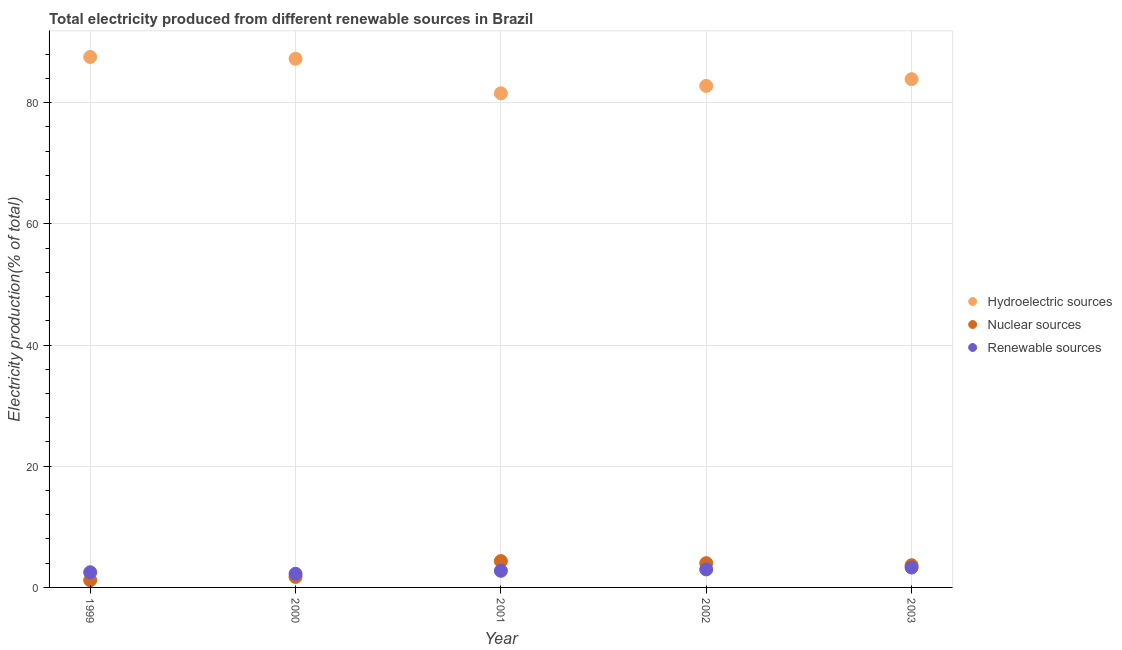How many different coloured dotlines are there?
Ensure brevity in your answer.  3. What is the percentage of electricity produced by hydroelectric sources in 2003?
Make the answer very short. 83.88. Across all years, what is the maximum percentage of electricity produced by hydroelectric sources?
Make the answer very short. 87.54. Across all years, what is the minimum percentage of electricity produced by hydroelectric sources?
Ensure brevity in your answer.  81.54. In which year was the percentage of electricity produced by hydroelectric sources minimum?
Provide a short and direct response. 2001. What is the total percentage of electricity produced by nuclear sources in the graph?
Offer a very short reply. 14.94. What is the difference between the percentage of electricity produced by hydroelectric sources in 1999 and that in 2001?
Your answer should be very brief. 5.99. What is the difference between the percentage of electricity produced by renewable sources in 2003 and the percentage of electricity produced by nuclear sources in 2001?
Offer a very short reply. -1.07. What is the average percentage of electricity produced by renewable sources per year?
Provide a succinct answer. 2.75. In the year 2003, what is the difference between the percentage of electricity produced by renewable sources and percentage of electricity produced by nuclear sources?
Offer a terse response. -0.39. In how many years, is the percentage of electricity produced by nuclear sources greater than 40 %?
Provide a succinct answer. 0. What is the ratio of the percentage of electricity produced by nuclear sources in 2002 to that in 2003?
Ensure brevity in your answer.  1.09. Is the difference between the percentage of electricity produced by renewable sources in 1999 and 2002 greater than the difference between the percentage of electricity produced by nuclear sources in 1999 and 2002?
Give a very brief answer. Yes. What is the difference between the highest and the second highest percentage of electricity produced by nuclear sources?
Ensure brevity in your answer.  0.34. What is the difference between the highest and the lowest percentage of electricity produced by renewable sources?
Offer a terse response. 1.03. In how many years, is the percentage of electricity produced by nuclear sources greater than the average percentage of electricity produced by nuclear sources taken over all years?
Your answer should be compact. 3. Is it the case that in every year, the sum of the percentage of electricity produced by hydroelectric sources and percentage of electricity produced by nuclear sources is greater than the percentage of electricity produced by renewable sources?
Your answer should be very brief. Yes. Does the percentage of electricity produced by renewable sources monotonically increase over the years?
Your answer should be compact. No. Is the percentage of electricity produced by nuclear sources strictly less than the percentage of electricity produced by hydroelectric sources over the years?
Your answer should be very brief. Yes. What is the difference between two consecutive major ticks on the Y-axis?
Your answer should be compact. 20. Are the values on the major ticks of Y-axis written in scientific E-notation?
Your answer should be compact. No. Does the graph contain any zero values?
Give a very brief answer. No. What is the title of the graph?
Ensure brevity in your answer.  Total electricity produced from different renewable sources in Brazil. Does "Negligence towards kids" appear as one of the legend labels in the graph?
Make the answer very short. No. What is the Electricity production(% of total) in Hydroelectric sources in 1999?
Provide a short and direct response. 87.54. What is the Electricity production(% of total) of Nuclear sources in 1999?
Offer a terse response. 1.19. What is the Electricity production(% of total) of Renewable sources in 1999?
Give a very brief answer. 2.5. What is the Electricity production(% of total) of Hydroelectric sources in 2000?
Give a very brief answer. 87.24. What is the Electricity production(% of total) of Nuclear sources in 2000?
Offer a terse response. 1.73. What is the Electricity production(% of total) of Renewable sources in 2000?
Provide a succinct answer. 2.25. What is the Electricity production(% of total) in Hydroelectric sources in 2001?
Make the answer very short. 81.54. What is the Electricity production(% of total) of Nuclear sources in 2001?
Your response must be concise. 4.35. What is the Electricity production(% of total) of Renewable sources in 2001?
Offer a very short reply. 2.74. What is the Electricity production(% of total) in Hydroelectric sources in 2002?
Your response must be concise. 82.76. What is the Electricity production(% of total) of Nuclear sources in 2002?
Provide a succinct answer. 4. What is the Electricity production(% of total) in Renewable sources in 2002?
Make the answer very short. 2.97. What is the Electricity production(% of total) of Hydroelectric sources in 2003?
Provide a succinct answer. 83.88. What is the Electricity production(% of total) of Nuclear sources in 2003?
Offer a terse response. 3.67. What is the Electricity production(% of total) of Renewable sources in 2003?
Your answer should be compact. 3.28. Across all years, what is the maximum Electricity production(% of total) of Hydroelectric sources?
Make the answer very short. 87.54. Across all years, what is the maximum Electricity production(% of total) in Nuclear sources?
Provide a succinct answer. 4.35. Across all years, what is the maximum Electricity production(% of total) in Renewable sources?
Ensure brevity in your answer.  3.28. Across all years, what is the minimum Electricity production(% of total) of Hydroelectric sources?
Your answer should be compact. 81.54. Across all years, what is the minimum Electricity production(% of total) of Nuclear sources?
Your answer should be very brief. 1.19. Across all years, what is the minimum Electricity production(% of total) of Renewable sources?
Offer a terse response. 2.25. What is the total Electricity production(% of total) of Hydroelectric sources in the graph?
Keep it short and to the point. 422.97. What is the total Electricity production(% of total) of Nuclear sources in the graph?
Make the answer very short. 14.94. What is the total Electricity production(% of total) of Renewable sources in the graph?
Your answer should be compact. 13.75. What is the difference between the Electricity production(% of total) in Hydroelectric sources in 1999 and that in 2000?
Offer a very short reply. 0.29. What is the difference between the Electricity production(% of total) of Nuclear sources in 1999 and that in 2000?
Provide a succinct answer. -0.54. What is the difference between the Electricity production(% of total) in Renewable sources in 1999 and that in 2000?
Give a very brief answer. 0.25. What is the difference between the Electricity production(% of total) of Hydroelectric sources in 1999 and that in 2001?
Your answer should be very brief. 5.99. What is the difference between the Electricity production(% of total) of Nuclear sources in 1999 and that in 2001?
Give a very brief answer. -3.16. What is the difference between the Electricity production(% of total) of Renewable sources in 1999 and that in 2001?
Provide a short and direct response. -0.24. What is the difference between the Electricity production(% of total) in Hydroelectric sources in 1999 and that in 2002?
Offer a terse response. 4.77. What is the difference between the Electricity production(% of total) of Nuclear sources in 1999 and that in 2002?
Your answer should be very brief. -2.81. What is the difference between the Electricity production(% of total) of Renewable sources in 1999 and that in 2002?
Provide a succinct answer. -0.47. What is the difference between the Electricity production(% of total) of Hydroelectric sources in 1999 and that in 2003?
Provide a succinct answer. 3.65. What is the difference between the Electricity production(% of total) in Nuclear sources in 1999 and that in 2003?
Your answer should be very brief. -2.48. What is the difference between the Electricity production(% of total) of Renewable sources in 1999 and that in 2003?
Your answer should be very brief. -0.78. What is the difference between the Electricity production(% of total) in Hydroelectric sources in 2000 and that in 2001?
Offer a very short reply. 5.7. What is the difference between the Electricity production(% of total) of Nuclear sources in 2000 and that in 2001?
Keep it short and to the point. -2.61. What is the difference between the Electricity production(% of total) in Renewable sources in 2000 and that in 2001?
Give a very brief answer. -0.5. What is the difference between the Electricity production(% of total) of Hydroelectric sources in 2000 and that in 2002?
Keep it short and to the point. 4.48. What is the difference between the Electricity production(% of total) in Nuclear sources in 2000 and that in 2002?
Give a very brief answer. -2.27. What is the difference between the Electricity production(% of total) of Renewable sources in 2000 and that in 2002?
Give a very brief answer. -0.73. What is the difference between the Electricity production(% of total) of Hydroelectric sources in 2000 and that in 2003?
Make the answer very short. 3.36. What is the difference between the Electricity production(% of total) of Nuclear sources in 2000 and that in 2003?
Make the answer very short. -1.93. What is the difference between the Electricity production(% of total) of Renewable sources in 2000 and that in 2003?
Ensure brevity in your answer.  -1.03. What is the difference between the Electricity production(% of total) of Hydroelectric sources in 2001 and that in 2002?
Offer a very short reply. -1.22. What is the difference between the Electricity production(% of total) of Nuclear sources in 2001 and that in 2002?
Ensure brevity in your answer.  0.34. What is the difference between the Electricity production(% of total) of Renewable sources in 2001 and that in 2002?
Give a very brief answer. -0.23. What is the difference between the Electricity production(% of total) of Hydroelectric sources in 2001 and that in 2003?
Your response must be concise. -2.34. What is the difference between the Electricity production(% of total) in Nuclear sources in 2001 and that in 2003?
Make the answer very short. 0.68. What is the difference between the Electricity production(% of total) in Renewable sources in 2001 and that in 2003?
Give a very brief answer. -0.54. What is the difference between the Electricity production(% of total) in Hydroelectric sources in 2002 and that in 2003?
Provide a succinct answer. -1.12. What is the difference between the Electricity production(% of total) of Nuclear sources in 2002 and that in 2003?
Provide a succinct answer. 0.34. What is the difference between the Electricity production(% of total) of Renewable sources in 2002 and that in 2003?
Make the answer very short. -0.31. What is the difference between the Electricity production(% of total) of Hydroelectric sources in 1999 and the Electricity production(% of total) of Nuclear sources in 2000?
Your answer should be compact. 85.8. What is the difference between the Electricity production(% of total) in Hydroelectric sources in 1999 and the Electricity production(% of total) in Renewable sources in 2000?
Provide a short and direct response. 85.29. What is the difference between the Electricity production(% of total) of Nuclear sources in 1999 and the Electricity production(% of total) of Renewable sources in 2000?
Your answer should be compact. -1.06. What is the difference between the Electricity production(% of total) in Hydroelectric sources in 1999 and the Electricity production(% of total) in Nuclear sources in 2001?
Provide a succinct answer. 83.19. What is the difference between the Electricity production(% of total) in Hydroelectric sources in 1999 and the Electricity production(% of total) in Renewable sources in 2001?
Ensure brevity in your answer.  84.79. What is the difference between the Electricity production(% of total) of Nuclear sources in 1999 and the Electricity production(% of total) of Renewable sources in 2001?
Your response must be concise. -1.56. What is the difference between the Electricity production(% of total) of Hydroelectric sources in 1999 and the Electricity production(% of total) of Nuclear sources in 2002?
Make the answer very short. 83.53. What is the difference between the Electricity production(% of total) of Hydroelectric sources in 1999 and the Electricity production(% of total) of Renewable sources in 2002?
Your answer should be very brief. 84.56. What is the difference between the Electricity production(% of total) of Nuclear sources in 1999 and the Electricity production(% of total) of Renewable sources in 2002?
Offer a very short reply. -1.79. What is the difference between the Electricity production(% of total) in Hydroelectric sources in 1999 and the Electricity production(% of total) in Nuclear sources in 2003?
Ensure brevity in your answer.  83.87. What is the difference between the Electricity production(% of total) of Hydroelectric sources in 1999 and the Electricity production(% of total) of Renewable sources in 2003?
Your answer should be compact. 84.26. What is the difference between the Electricity production(% of total) in Nuclear sources in 1999 and the Electricity production(% of total) in Renewable sources in 2003?
Your answer should be very brief. -2.09. What is the difference between the Electricity production(% of total) of Hydroelectric sources in 2000 and the Electricity production(% of total) of Nuclear sources in 2001?
Provide a short and direct response. 82.9. What is the difference between the Electricity production(% of total) of Hydroelectric sources in 2000 and the Electricity production(% of total) of Renewable sources in 2001?
Provide a short and direct response. 84.5. What is the difference between the Electricity production(% of total) of Nuclear sources in 2000 and the Electricity production(% of total) of Renewable sources in 2001?
Your answer should be compact. -1.01. What is the difference between the Electricity production(% of total) in Hydroelectric sources in 2000 and the Electricity production(% of total) in Nuclear sources in 2002?
Give a very brief answer. 83.24. What is the difference between the Electricity production(% of total) of Hydroelectric sources in 2000 and the Electricity production(% of total) of Renewable sources in 2002?
Offer a very short reply. 84.27. What is the difference between the Electricity production(% of total) of Nuclear sources in 2000 and the Electricity production(% of total) of Renewable sources in 2002?
Make the answer very short. -1.24. What is the difference between the Electricity production(% of total) of Hydroelectric sources in 2000 and the Electricity production(% of total) of Nuclear sources in 2003?
Your answer should be compact. 83.58. What is the difference between the Electricity production(% of total) of Hydroelectric sources in 2000 and the Electricity production(% of total) of Renewable sources in 2003?
Offer a terse response. 83.96. What is the difference between the Electricity production(% of total) in Nuclear sources in 2000 and the Electricity production(% of total) in Renewable sources in 2003?
Make the answer very short. -1.55. What is the difference between the Electricity production(% of total) of Hydroelectric sources in 2001 and the Electricity production(% of total) of Nuclear sources in 2002?
Your answer should be compact. 77.54. What is the difference between the Electricity production(% of total) in Hydroelectric sources in 2001 and the Electricity production(% of total) in Renewable sources in 2002?
Your answer should be very brief. 78.57. What is the difference between the Electricity production(% of total) of Nuclear sources in 2001 and the Electricity production(% of total) of Renewable sources in 2002?
Your answer should be compact. 1.37. What is the difference between the Electricity production(% of total) in Hydroelectric sources in 2001 and the Electricity production(% of total) in Nuclear sources in 2003?
Provide a succinct answer. 77.88. What is the difference between the Electricity production(% of total) in Hydroelectric sources in 2001 and the Electricity production(% of total) in Renewable sources in 2003?
Ensure brevity in your answer.  78.26. What is the difference between the Electricity production(% of total) in Nuclear sources in 2001 and the Electricity production(% of total) in Renewable sources in 2003?
Offer a terse response. 1.07. What is the difference between the Electricity production(% of total) of Hydroelectric sources in 2002 and the Electricity production(% of total) of Nuclear sources in 2003?
Keep it short and to the point. 79.1. What is the difference between the Electricity production(% of total) in Hydroelectric sources in 2002 and the Electricity production(% of total) in Renewable sources in 2003?
Your answer should be compact. 79.48. What is the difference between the Electricity production(% of total) of Nuclear sources in 2002 and the Electricity production(% of total) of Renewable sources in 2003?
Your answer should be compact. 0.72. What is the average Electricity production(% of total) of Hydroelectric sources per year?
Provide a short and direct response. 84.59. What is the average Electricity production(% of total) of Nuclear sources per year?
Offer a terse response. 2.99. What is the average Electricity production(% of total) of Renewable sources per year?
Give a very brief answer. 2.75. In the year 1999, what is the difference between the Electricity production(% of total) of Hydroelectric sources and Electricity production(% of total) of Nuclear sources?
Your answer should be compact. 86.35. In the year 1999, what is the difference between the Electricity production(% of total) of Hydroelectric sources and Electricity production(% of total) of Renewable sources?
Your answer should be very brief. 85.04. In the year 1999, what is the difference between the Electricity production(% of total) in Nuclear sources and Electricity production(% of total) in Renewable sources?
Offer a terse response. -1.31. In the year 2000, what is the difference between the Electricity production(% of total) of Hydroelectric sources and Electricity production(% of total) of Nuclear sources?
Your response must be concise. 85.51. In the year 2000, what is the difference between the Electricity production(% of total) of Hydroelectric sources and Electricity production(% of total) of Renewable sources?
Your answer should be compact. 85. In the year 2000, what is the difference between the Electricity production(% of total) in Nuclear sources and Electricity production(% of total) in Renewable sources?
Offer a very short reply. -0.52. In the year 2001, what is the difference between the Electricity production(% of total) in Hydroelectric sources and Electricity production(% of total) in Nuclear sources?
Your answer should be compact. 77.2. In the year 2001, what is the difference between the Electricity production(% of total) in Hydroelectric sources and Electricity production(% of total) in Renewable sources?
Your answer should be compact. 78.8. In the year 2001, what is the difference between the Electricity production(% of total) of Nuclear sources and Electricity production(% of total) of Renewable sources?
Provide a short and direct response. 1.6. In the year 2002, what is the difference between the Electricity production(% of total) of Hydroelectric sources and Electricity production(% of total) of Nuclear sources?
Your answer should be very brief. 78.76. In the year 2002, what is the difference between the Electricity production(% of total) in Hydroelectric sources and Electricity production(% of total) in Renewable sources?
Your response must be concise. 79.79. In the year 2002, what is the difference between the Electricity production(% of total) in Nuclear sources and Electricity production(% of total) in Renewable sources?
Make the answer very short. 1.03. In the year 2003, what is the difference between the Electricity production(% of total) in Hydroelectric sources and Electricity production(% of total) in Nuclear sources?
Give a very brief answer. 80.22. In the year 2003, what is the difference between the Electricity production(% of total) in Hydroelectric sources and Electricity production(% of total) in Renewable sources?
Provide a succinct answer. 80.6. In the year 2003, what is the difference between the Electricity production(% of total) in Nuclear sources and Electricity production(% of total) in Renewable sources?
Provide a succinct answer. 0.39. What is the ratio of the Electricity production(% of total) of Nuclear sources in 1999 to that in 2000?
Make the answer very short. 0.69. What is the ratio of the Electricity production(% of total) in Renewable sources in 1999 to that in 2000?
Your answer should be very brief. 1.11. What is the ratio of the Electricity production(% of total) in Hydroelectric sources in 1999 to that in 2001?
Provide a succinct answer. 1.07. What is the ratio of the Electricity production(% of total) of Nuclear sources in 1999 to that in 2001?
Give a very brief answer. 0.27. What is the ratio of the Electricity production(% of total) in Renewable sources in 1999 to that in 2001?
Give a very brief answer. 0.91. What is the ratio of the Electricity production(% of total) in Hydroelectric sources in 1999 to that in 2002?
Provide a succinct answer. 1.06. What is the ratio of the Electricity production(% of total) of Nuclear sources in 1999 to that in 2002?
Provide a succinct answer. 0.3. What is the ratio of the Electricity production(% of total) in Renewable sources in 1999 to that in 2002?
Your answer should be very brief. 0.84. What is the ratio of the Electricity production(% of total) of Hydroelectric sources in 1999 to that in 2003?
Your answer should be compact. 1.04. What is the ratio of the Electricity production(% of total) in Nuclear sources in 1999 to that in 2003?
Offer a very short reply. 0.32. What is the ratio of the Electricity production(% of total) of Renewable sources in 1999 to that in 2003?
Offer a terse response. 0.76. What is the ratio of the Electricity production(% of total) of Hydroelectric sources in 2000 to that in 2001?
Give a very brief answer. 1.07. What is the ratio of the Electricity production(% of total) in Nuclear sources in 2000 to that in 2001?
Ensure brevity in your answer.  0.4. What is the ratio of the Electricity production(% of total) in Renewable sources in 2000 to that in 2001?
Provide a short and direct response. 0.82. What is the ratio of the Electricity production(% of total) of Hydroelectric sources in 2000 to that in 2002?
Your answer should be compact. 1.05. What is the ratio of the Electricity production(% of total) of Nuclear sources in 2000 to that in 2002?
Your answer should be very brief. 0.43. What is the ratio of the Electricity production(% of total) of Renewable sources in 2000 to that in 2002?
Provide a succinct answer. 0.76. What is the ratio of the Electricity production(% of total) in Hydroelectric sources in 2000 to that in 2003?
Provide a short and direct response. 1.04. What is the ratio of the Electricity production(% of total) of Nuclear sources in 2000 to that in 2003?
Provide a succinct answer. 0.47. What is the ratio of the Electricity production(% of total) in Renewable sources in 2000 to that in 2003?
Your answer should be very brief. 0.69. What is the ratio of the Electricity production(% of total) in Hydroelectric sources in 2001 to that in 2002?
Your answer should be very brief. 0.99. What is the ratio of the Electricity production(% of total) in Nuclear sources in 2001 to that in 2002?
Ensure brevity in your answer.  1.09. What is the ratio of the Electricity production(% of total) of Renewable sources in 2001 to that in 2002?
Offer a very short reply. 0.92. What is the ratio of the Electricity production(% of total) of Hydroelectric sources in 2001 to that in 2003?
Offer a terse response. 0.97. What is the ratio of the Electricity production(% of total) in Nuclear sources in 2001 to that in 2003?
Ensure brevity in your answer.  1.19. What is the ratio of the Electricity production(% of total) in Renewable sources in 2001 to that in 2003?
Provide a succinct answer. 0.84. What is the ratio of the Electricity production(% of total) of Hydroelectric sources in 2002 to that in 2003?
Make the answer very short. 0.99. What is the ratio of the Electricity production(% of total) in Nuclear sources in 2002 to that in 2003?
Ensure brevity in your answer.  1.09. What is the ratio of the Electricity production(% of total) of Renewable sources in 2002 to that in 2003?
Keep it short and to the point. 0.91. What is the difference between the highest and the second highest Electricity production(% of total) in Hydroelectric sources?
Keep it short and to the point. 0.29. What is the difference between the highest and the second highest Electricity production(% of total) in Nuclear sources?
Your response must be concise. 0.34. What is the difference between the highest and the second highest Electricity production(% of total) in Renewable sources?
Offer a very short reply. 0.31. What is the difference between the highest and the lowest Electricity production(% of total) in Hydroelectric sources?
Provide a short and direct response. 5.99. What is the difference between the highest and the lowest Electricity production(% of total) of Nuclear sources?
Your answer should be very brief. 3.16. What is the difference between the highest and the lowest Electricity production(% of total) in Renewable sources?
Your response must be concise. 1.03. 